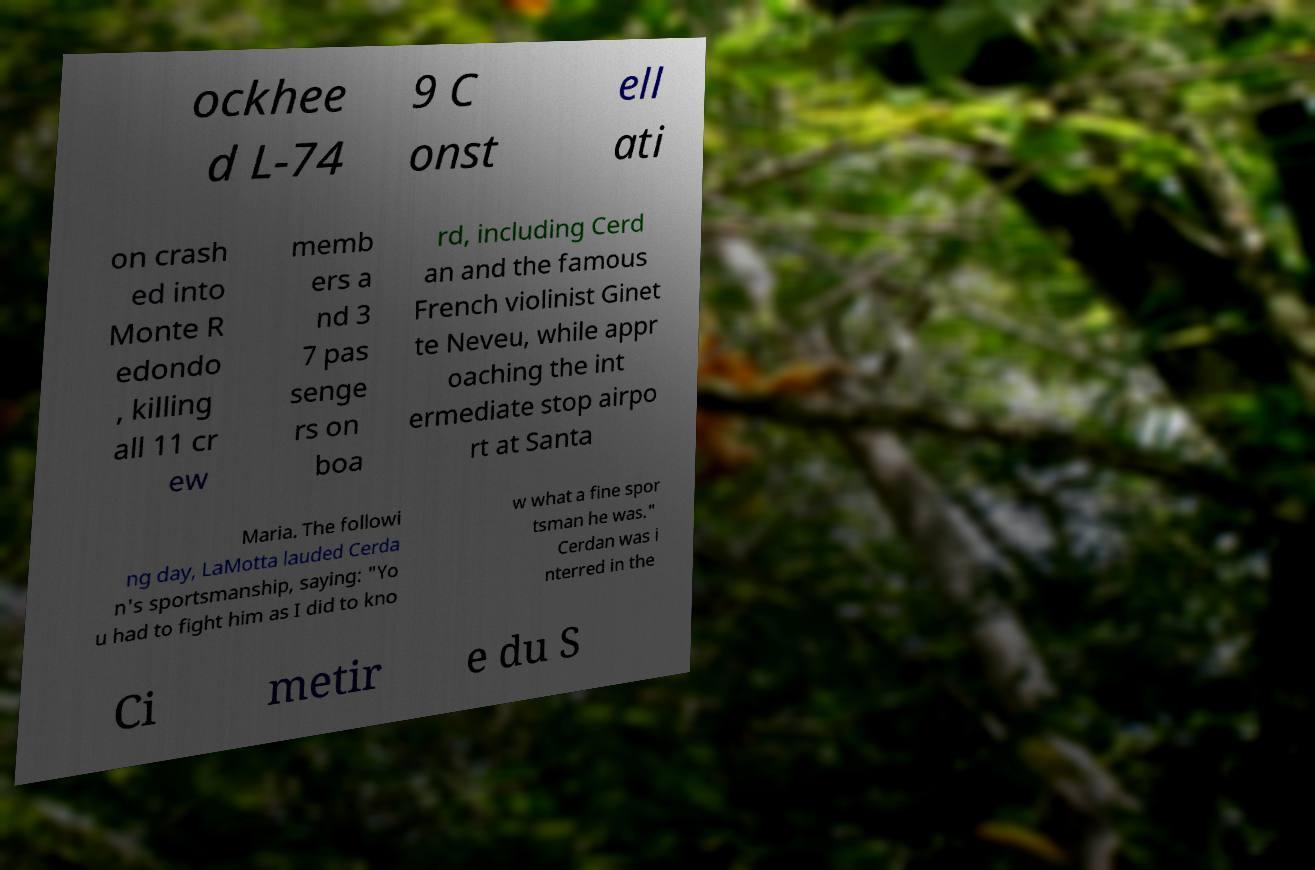Could you assist in decoding the text presented in this image and type it out clearly? ockhee d L-74 9 C onst ell ati on crash ed into Monte R edondo , killing all 11 cr ew memb ers a nd 3 7 pas senge rs on boa rd, including Cerd an and the famous French violinist Ginet te Neveu, while appr oaching the int ermediate stop airpo rt at Santa Maria. The followi ng day, LaMotta lauded Cerda n's sportsmanship, saying: "Yo u had to fight him as I did to kno w what a fine spor tsman he was." Cerdan was i nterred in the Ci metir e du S 